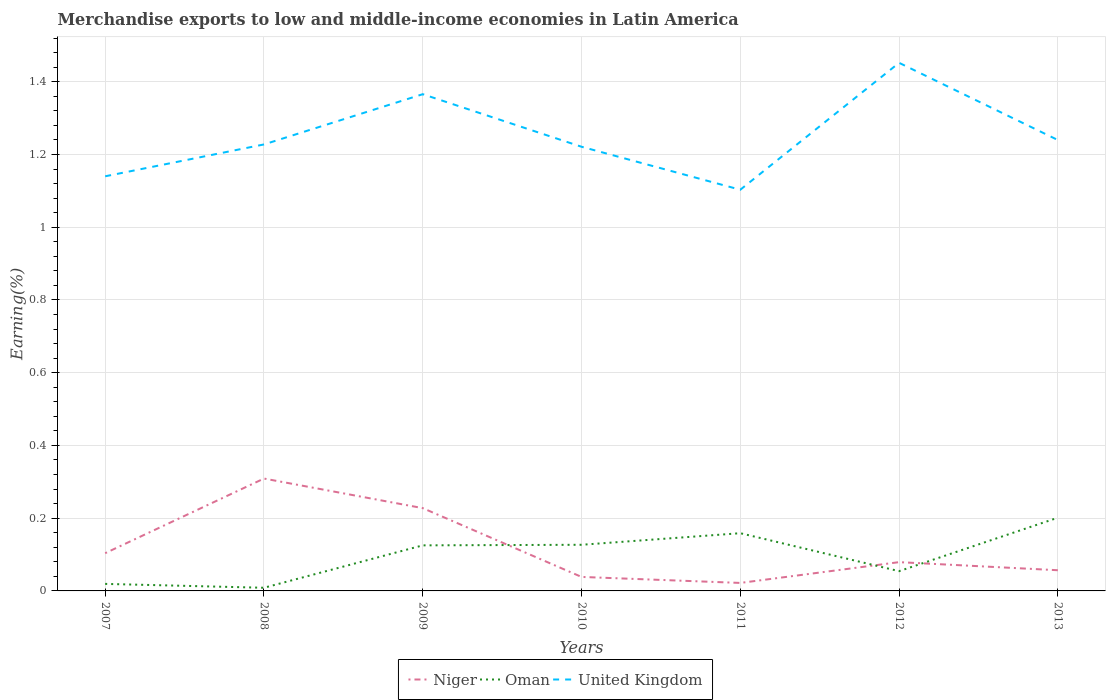How many different coloured lines are there?
Offer a very short reply. 3. Does the line corresponding to United Kingdom intersect with the line corresponding to Niger?
Ensure brevity in your answer.  No. Across all years, what is the maximum percentage of amount earned from merchandise exports in Oman?
Your answer should be compact. 0.01. In which year was the percentage of amount earned from merchandise exports in United Kingdom maximum?
Give a very brief answer. 2011. What is the total percentage of amount earned from merchandise exports in Oman in the graph?
Offer a very short reply. 0.01. What is the difference between the highest and the second highest percentage of amount earned from merchandise exports in Oman?
Give a very brief answer. 0.19. What is the difference between the highest and the lowest percentage of amount earned from merchandise exports in United Kingdom?
Give a very brief answer. 2. How many lines are there?
Give a very brief answer. 3. How many years are there in the graph?
Your response must be concise. 7. What is the difference between two consecutive major ticks on the Y-axis?
Offer a very short reply. 0.2. Are the values on the major ticks of Y-axis written in scientific E-notation?
Your answer should be compact. No. Where does the legend appear in the graph?
Offer a terse response. Bottom center. How many legend labels are there?
Offer a terse response. 3. How are the legend labels stacked?
Provide a short and direct response. Horizontal. What is the title of the graph?
Give a very brief answer. Merchandise exports to low and middle-income economies in Latin America. Does "Ghana" appear as one of the legend labels in the graph?
Your response must be concise. No. What is the label or title of the Y-axis?
Keep it short and to the point. Earning(%). What is the Earning(%) of Niger in 2007?
Your answer should be very brief. 0.1. What is the Earning(%) in Oman in 2007?
Your answer should be very brief. 0.02. What is the Earning(%) of United Kingdom in 2007?
Make the answer very short. 1.14. What is the Earning(%) of Niger in 2008?
Provide a short and direct response. 0.31. What is the Earning(%) of Oman in 2008?
Make the answer very short. 0.01. What is the Earning(%) of United Kingdom in 2008?
Your answer should be very brief. 1.23. What is the Earning(%) in Niger in 2009?
Your answer should be compact. 0.23. What is the Earning(%) in Oman in 2009?
Offer a very short reply. 0.13. What is the Earning(%) in United Kingdom in 2009?
Make the answer very short. 1.37. What is the Earning(%) in Niger in 2010?
Offer a very short reply. 0.04. What is the Earning(%) in Oman in 2010?
Your answer should be very brief. 0.13. What is the Earning(%) in United Kingdom in 2010?
Provide a succinct answer. 1.22. What is the Earning(%) of Niger in 2011?
Ensure brevity in your answer.  0.02. What is the Earning(%) of Oman in 2011?
Provide a succinct answer. 0.16. What is the Earning(%) of United Kingdom in 2011?
Your response must be concise. 1.1. What is the Earning(%) in Niger in 2012?
Your response must be concise. 0.08. What is the Earning(%) in Oman in 2012?
Offer a very short reply. 0.05. What is the Earning(%) in United Kingdom in 2012?
Provide a short and direct response. 1.45. What is the Earning(%) of Niger in 2013?
Keep it short and to the point. 0.06. What is the Earning(%) of Oman in 2013?
Offer a very short reply. 0.2. What is the Earning(%) of United Kingdom in 2013?
Provide a succinct answer. 1.24. Across all years, what is the maximum Earning(%) of Niger?
Give a very brief answer. 0.31. Across all years, what is the maximum Earning(%) of Oman?
Make the answer very short. 0.2. Across all years, what is the maximum Earning(%) of United Kingdom?
Your answer should be compact. 1.45. Across all years, what is the minimum Earning(%) in Niger?
Keep it short and to the point. 0.02. Across all years, what is the minimum Earning(%) in Oman?
Provide a short and direct response. 0.01. Across all years, what is the minimum Earning(%) in United Kingdom?
Your response must be concise. 1.1. What is the total Earning(%) of Niger in the graph?
Offer a very short reply. 0.84. What is the total Earning(%) of Oman in the graph?
Ensure brevity in your answer.  0.69. What is the total Earning(%) of United Kingdom in the graph?
Offer a very short reply. 8.75. What is the difference between the Earning(%) in Niger in 2007 and that in 2008?
Your response must be concise. -0.21. What is the difference between the Earning(%) of Oman in 2007 and that in 2008?
Give a very brief answer. 0.01. What is the difference between the Earning(%) in United Kingdom in 2007 and that in 2008?
Provide a succinct answer. -0.09. What is the difference between the Earning(%) in Niger in 2007 and that in 2009?
Offer a very short reply. -0.12. What is the difference between the Earning(%) in Oman in 2007 and that in 2009?
Ensure brevity in your answer.  -0.11. What is the difference between the Earning(%) in United Kingdom in 2007 and that in 2009?
Your response must be concise. -0.23. What is the difference between the Earning(%) of Niger in 2007 and that in 2010?
Make the answer very short. 0.07. What is the difference between the Earning(%) of Oman in 2007 and that in 2010?
Your answer should be compact. -0.11. What is the difference between the Earning(%) in United Kingdom in 2007 and that in 2010?
Provide a succinct answer. -0.08. What is the difference between the Earning(%) of Niger in 2007 and that in 2011?
Make the answer very short. 0.08. What is the difference between the Earning(%) of Oman in 2007 and that in 2011?
Keep it short and to the point. -0.14. What is the difference between the Earning(%) of United Kingdom in 2007 and that in 2011?
Your answer should be very brief. 0.04. What is the difference between the Earning(%) in Niger in 2007 and that in 2012?
Offer a very short reply. 0.02. What is the difference between the Earning(%) of Oman in 2007 and that in 2012?
Provide a succinct answer. -0.04. What is the difference between the Earning(%) of United Kingdom in 2007 and that in 2012?
Give a very brief answer. -0.31. What is the difference between the Earning(%) in Niger in 2007 and that in 2013?
Keep it short and to the point. 0.05. What is the difference between the Earning(%) of Oman in 2007 and that in 2013?
Offer a very short reply. -0.18. What is the difference between the Earning(%) in United Kingdom in 2007 and that in 2013?
Make the answer very short. -0.1. What is the difference between the Earning(%) of Niger in 2008 and that in 2009?
Keep it short and to the point. 0.08. What is the difference between the Earning(%) in Oman in 2008 and that in 2009?
Your answer should be very brief. -0.12. What is the difference between the Earning(%) in United Kingdom in 2008 and that in 2009?
Give a very brief answer. -0.14. What is the difference between the Earning(%) in Niger in 2008 and that in 2010?
Provide a short and direct response. 0.27. What is the difference between the Earning(%) of Oman in 2008 and that in 2010?
Offer a very short reply. -0.12. What is the difference between the Earning(%) in United Kingdom in 2008 and that in 2010?
Give a very brief answer. 0.01. What is the difference between the Earning(%) in Niger in 2008 and that in 2011?
Provide a succinct answer. 0.29. What is the difference between the Earning(%) of United Kingdom in 2008 and that in 2011?
Keep it short and to the point. 0.12. What is the difference between the Earning(%) in Niger in 2008 and that in 2012?
Your response must be concise. 0.23. What is the difference between the Earning(%) in Oman in 2008 and that in 2012?
Your response must be concise. -0.05. What is the difference between the Earning(%) in United Kingdom in 2008 and that in 2012?
Offer a very short reply. -0.22. What is the difference between the Earning(%) of Niger in 2008 and that in 2013?
Keep it short and to the point. 0.25. What is the difference between the Earning(%) of Oman in 2008 and that in 2013?
Make the answer very short. -0.19. What is the difference between the Earning(%) of United Kingdom in 2008 and that in 2013?
Your response must be concise. -0.01. What is the difference between the Earning(%) in Niger in 2009 and that in 2010?
Your answer should be very brief. 0.19. What is the difference between the Earning(%) of Oman in 2009 and that in 2010?
Your response must be concise. -0. What is the difference between the Earning(%) in United Kingdom in 2009 and that in 2010?
Provide a short and direct response. 0.14. What is the difference between the Earning(%) in Niger in 2009 and that in 2011?
Provide a short and direct response. 0.21. What is the difference between the Earning(%) of Oman in 2009 and that in 2011?
Your answer should be very brief. -0.03. What is the difference between the Earning(%) in United Kingdom in 2009 and that in 2011?
Your answer should be compact. 0.26. What is the difference between the Earning(%) of Niger in 2009 and that in 2012?
Your response must be concise. 0.15. What is the difference between the Earning(%) of Oman in 2009 and that in 2012?
Give a very brief answer. 0.07. What is the difference between the Earning(%) in United Kingdom in 2009 and that in 2012?
Keep it short and to the point. -0.09. What is the difference between the Earning(%) of Niger in 2009 and that in 2013?
Your answer should be very brief. 0.17. What is the difference between the Earning(%) of Oman in 2009 and that in 2013?
Your answer should be very brief. -0.08. What is the difference between the Earning(%) of United Kingdom in 2009 and that in 2013?
Offer a very short reply. 0.13. What is the difference between the Earning(%) of Niger in 2010 and that in 2011?
Make the answer very short. 0.02. What is the difference between the Earning(%) in Oman in 2010 and that in 2011?
Offer a terse response. -0.03. What is the difference between the Earning(%) in United Kingdom in 2010 and that in 2011?
Your response must be concise. 0.12. What is the difference between the Earning(%) in Niger in 2010 and that in 2012?
Provide a short and direct response. -0.04. What is the difference between the Earning(%) in Oman in 2010 and that in 2012?
Ensure brevity in your answer.  0.07. What is the difference between the Earning(%) of United Kingdom in 2010 and that in 2012?
Give a very brief answer. -0.23. What is the difference between the Earning(%) of Niger in 2010 and that in 2013?
Keep it short and to the point. -0.02. What is the difference between the Earning(%) of Oman in 2010 and that in 2013?
Keep it short and to the point. -0.07. What is the difference between the Earning(%) of United Kingdom in 2010 and that in 2013?
Your answer should be compact. -0.02. What is the difference between the Earning(%) in Niger in 2011 and that in 2012?
Ensure brevity in your answer.  -0.06. What is the difference between the Earning(%) in Oman in 2011 and that in 2012?
Make the answer very short. 0.1. What is the difference between the Earning(%) in United Kingdom in 2011 and that in 2012?
Provide a succinct answer. -0.35. What is the difference between the Earning(%) of Niger in 2011 and that in 2013?
Provide a short and direct response. -0.03. What is the difference between the Earning(%) in Oman in 2011 and that in 2013?
Provide a succinct answer. -0.04. What is the difference between the Earning(%) of United Kingdom in 2011 and that in 2013?
Give a very brief answer. -0.14. What is the difference between the Earning(%) in Niger in 2012 and that in 2013?
Make the answer very short. 0.02. What is the difference between the Earning(%) in Oman in 2012 and that in 2013?
Offer a terse response. -0.15. What is the difference between the Earning(%) in United Kingdom in 2012 and that in 2013?
Ensure brevity in your answer.  0.21. What is the difference between the Earning(%) of Niger in 2007 and the Earning(%) of Oman in 2008?
Offer a terse response. 0.1. What is the difference between the Earning(%) in Niger in 2007 and the Earning(%) in United Kingdom in 2008?
Ensure brevity in your answer.  -1.12. What is the difference between the Earning(%) of Oman in 2007 and the Earning(%) of United Kingdom in 2008?
Offer a very short reply. -1.21. What is the difference between the Earning(%) in Niger in 2007 and the Earning(%) in Oman in 2009?
Provide a succinct answer. -0.02. What is the difference between the Earning(%) in Niger in 2007 and the Earning(%) in United Kingdom in 2009?
Give a very brief answer. -1.26. What is the difference between the Earning(%) in Oman in 2007 and the Earning(%) in United Kingdom in 2009?
Offer a terse response. -1.35. What is the difference between the Earning(%) of Niger in 2007 and the Earning(%) of Oman in 2010?
Your answer should be very brief. -0.02. What is the difference between the Earning(%) in Niger in 2007 and the Earning(%) in United Kingdom in 2010?
Your answer should be compact. -1.12. What is the difference between the Earning(%) in Oman in 2007 and the Earning(%) in United Kingdom in 2010?
Offer a very short reply. -1.2. What is the difference between the Earning(%) of Niger in 2007 and the Earning(%) of Oman in 2011?
Your answer should be compact. -0.06. What is the difference between the Earning(%) of Niger in 2007 and the Earning(%) of United Kingdom in 2011?
Make the answer very short. -1. What is the difference between the Earning(%) of Oman in 2007 and the Earning(%) of United Kingdom in 2011?
Provide a succinct answer. -1.08. What is the difference between the Earning(%) of Niger in 2007 and the Earning(%) of Oman in 2012?
Keep it short and to the point. 0.05. What is the difference between the Earning(%) of Niger in 2007 and the Earning(%) of United Kingdom in 2012?
Provide a succinct answer. -1.35. What is the difference between the Earning(%) of Oman in 2007 and the Earning(%) of United Kingdom in 2012?
Provide a succinct answer. -1.43. What is the difference between the Earning(%) of Niger in 2007 and the Earning(%) of Oman in 2013?
Give a very brief answer. -0.1. What is the difference between the Earning(%) in Niger in 2007 and the Earning(%) in United Kingdom in 2013?
Make the answer very short. -1.14. What is the difference between the Earning(%) of Oman in 2007 and the Earning(%) of United Kingdom in 2013?
Provide a succinct answer. -1.22. What is the difference between the Earning(%) in Niger in 2008 and the Earning(%) in Oman in 2009?
Provide a short and direct response. 0.18. What is the difference between the Earning(%) in Niger in 2008 and the Earning(%) in United Kingdom in 2009?
Provide a succinct answer. -1.06. What is the difference between the Earning(%) of Oman in 2008 and the Earning(%) of United Kingdom in 2009?
Give a very brief answer. -1.36. What is the difference between the Earning(%) of Niger in 2008 and the Earning(%) of Oman in 2010?
Keep it short and to the point. 0.18. What is the difference between the Earning(%) in Niger in 2008 and the Earning(%) in United Kingdom in 2010?
Offer a very short reply. -0.91. What is the difference between the Earning(%) in Oman in 2008 and the Earning(%) in United Kingdom in 2010?
Keep it short and to the point. -1.21. What is the difference between the Earning(%) of Niger in 2008 and the Earning(%) of Oman in 2011?
Your response must be concise. 0.15. What is the difference between the Earning(%) of Niger in 2008 and the Earning(%) of United Kingdom in 2011?
Ensure brevity in your answer.  -0.79. What is the difference between the Earning(%) in Oman in 2008 and the Earning(%) in United Kingdom in 2011?
Your answer should be very brief. -1.09. What is the difference between the Earning(%) of Niger in 2008 and the Earning(%) of Oman in 2012?
Your answer should be compact. 0.25. What is the difference between the Earning(%) of Niger in 2008 and the Earning(%) of United Kingdom in 2012?
Offer a very short reply. -1.14. What is the difference between the Earning(%) in Oman in 2008 and the Earning(%) in United Kingdom in 2012?
Provide a succinct answer. -1.44. What is the difference between the Earning(%) in Niger in 2008 and the Earning(%) in Oman in 2013?
Your answer should be compact. 0.11. What is the difference between the Earning(%) of Niger in 2008 and the Earning(%) of United Kingdom in 2013?
Ensure brevity in your answer.  -0.93. What is the difference between the Earning(%) in Oman in 2008 and the Earning(%) in United Kingdom in 2013?
Give a very brief answer. -1.23. What is the difference between the Earning(%) of Niger in 2009 and the Earning(%) of Oman in 2010?
Offer a terse response. 0.1. What is the difference between the Earning(%) of Niger in 2009 and the Earning(%) of United Kingdom in 2010?
Provide a short and direct response. -0.99. What is the difference between the Earning(%) of Oman in 2009 and the Earning(%) of United Kingdom in 2010?
Your answer should be very brief. -1.1. What is the difference between the Earning(%) of Niger in 2009 and the Earning(%) of Oman in 2011?
Ensure brevity in your answer.  0.07. What is the difference between the Earning(%) of Niger in 2009 and the Earning(%) of United Kingdom in 2011?
Your response must be concise. -0.88. What is the difference between the Earning(%) of Oman in 2009 and the Earning(%) of United Kingdom in 2011?
Keep it short and to the point. -0.98. What is the difference between the Earning(%) in Niger in 2009 and the Earning(%) in Oman in 2012?
Your response must be concise. 0.17. What is the difference between the Earning(%) of Niger in 2009 and the Earning(%) of United Kingdom in 2012?
Offer a terse response. -1.22. What is the difference between the Earning(%) in Oman in 2009 and the Earning(%) in United Kingdom in 2012?
Give a very brief answer. -1.33. What is the difference between the Earning(%) of Niger in 2009 and the Earning(%) of Oman in 2013?
Give a very brief answer. 0.03. What is the difference between the Earning(%) of Niger in 2009 and the Earning(%) of United Kingdom in 2013?
Provide a succinct answer. -1.01. What is the difference between the Earning(%) of Oman in 2009 and the Earning(%) of United Kingdom in 2013?
Offer a terse response. -1.11. What is the difference between the Earning(%) of Niger in 2010 and the Earning(%) of Oman in 2011?
Make the answer very short. -0.12. What is the difference between the Earning(%) of Niger in 2010 and the Earning(%) of United Kingdom in 2011?
Your answer should be compact. -1.06. What is the difference between the Earning(%) in Oman in 2010 and the Earning(%) in United Kingdom in 2011?
Make the answer very short. -0.98. What is the difference between the Earning(%) of Niger in 2010 and the Earning(%) of Oman in 2012?
Keep it short and to the point. -0.02. What is the difference between the Earning(%) of Niger in 2010 and the Earning(%) of United Kingdom in 2012?
Your answer should be very brief. -1.41. What is the difference between the Earning(%) of Oman in 2010 and the Earning(%) of United Kingdom in 2012?
Give a very brief answer. -1.33. What is the difference between the Earning(%) in Niger in 2010 and the Earning(%) in Oman in 2013?
Offer a terse response. -0.16. What is the difference between the Earning(%) in Niger in 2010 and the Earning(%) in United Kingdom in 2013?
Offer a terse response. -1.2. What is the difference between the Earning(%) in Oman in 2010 and the Earning(%) in United Kingdom in 2013?
Your response must be concise. -1.11. What is the difference between the Earning(%) of Niger in 2011 and the Earning(%) of Oman in 2012?
Your answer should be very brief. -0.03. What is the difference between the Earning(%) in Niger in 2011 and the Earning(%) in United Kingdom in 2012?
Keep it short and to the point. -1.43. What is the difference between the Earning(%) of Oman in 2011 and the Earning(%) of United Kingdom in 2012?
Ensure brevity in your answer.  -1.29. What is the difference between the Earning(%) in Niger in 2011 and the Earning(%) in Oman in 2013?
Provide a short and direct response. -0.18. What is the difference between the Earning(%) in Niger in 2011 and the Earning(%) in United Kingdom in 2013?
Your response must be concise. -1.22. What is the difference between the Earning(%) in Oman in 2011 and the Earning(%) in United Kingdom in 2013?
Keep it short and to the point. -1.08. What is the difference between the Earning(%) in Niger in 2012 and the Earning(%) in Oman in 2013?
Make the answer very short. -0.12. What is the difference between the Earning(%) in Niger in 2012 and the Earning(%) in United Kingdom in 2013?
Your answer should be very brief. -1.16. What is the difference between the Earning(%) in Oman in 2012 and the Earning(%) in United Kingdom in 2013?
Provide a succinct answer. -1.19. What is the average Earning(%) of Niger per year?
Your answer should be very brief. 0.12. What is the average Earning(%) of Oman per year?
Offer a terse response. 0.1. What is the average Earning(%) of United Kingdom per year?
Offer a very short reply. 1.25. In the year 2007, what is the difference between the Earning(%) in Niger and Earning(%) in Oman?
Provide a succinct answer. 0.08. In the year 2007, what is the difference between the Earning(%) in Niger and Earning(%) in United Kingdom?
Provide a short and direct response. -1.04. In the year 2007, what is the difference between the Earning(%) of Oman and Earning(%) of United Kingdom?
Offer a very short reply. -1.12. In the year 2008, what is the difference between the Earning(%) in Niger and Earning(%) in Oman?
Provide a succinct answer. 0.3. In the year 2008, what is the difference between the Earning(%) in Niger and Earning(%) in United Kingdom?
Your answer should be very brief. -0.92. In the year 2008, what is the difference between the Earning(%) of Oman and Earning(%) of United Kingdom?
Keep it short and to the point. -1.22. In the year 2009, what is the difference between the Earning(%) in Niger and Earning(%) in Oman?
Your response must be concise. 0.1. In the year 2009, what is the difference between the Earning(%) of Niger and Earning(%) of United Kingdom?
Your response must be concise. -1.14. In the year 2009, what is the difference between the Earning(%) in Oman and Earning(%) in United Kingdom?
Provide a short and direct response. -1.24. In the year 2010, what is the difference between the Earning(%) of Niger and Earning(%) of Oman?
Give a very brief answer. -0.09. In the year 2010, what is the difference between the Earning(%) of Niger and Earning(%) of United Kingdom?
Your response must be concise. -1.18. In the year 2010, what is the difference between the Earning(%) of Oman and Earning(%) of United Kingdom?
Offer a very short reply. -1.09. In the year 2011, what is the difference between the Earning(%) of Niger and Earning(%) of Oman?
Offer a very short reply. -0.14. In the year 2011, what is the difference between the Earning(%) in Niger and Earning(%) in United Kingdom?
Make the answer very short. -1.08. In the year 2011, what is the difference between the Earning(%) in Oman and Earning(%) in United Kingdom?
Give a very brief answer. -0.94. In the year 2012, what is the difference between the Earning(%) of Niger and Earning(%) of Oman?
Give a very brief answer. 0.02. In the year 2012, what is the difference between the Earning(%) of Niger and Earning(%) of United Kingdom?
Make the answer very short. -1.37. In the year 2012, what is the difference between the Earning(%) of Oman and Earning(%) of United Kingdom?
Give a very brief answer. -1.4. In the year 2013, what is the difference between the Earning(%) in Niger and Earning(%) in Oman?
Provide a short and direct response. -0.14. In the year 2013, what is the difference between the Earning(%) in Niger and Earning(%) in United Kingdom?
Your answer should be very brief. -1.18. In the year 2013, what is the difference between the Earning(%) in Oman and Earning(%) in United Kingdom?
Your answer should be very brief. -1.04. What is the ratio of the Earning(%) of Niger in 2007 to that in 2008?
Offer a terse response. 0.34. What is the ratio of the Earning(%) in Oman in 2007 to that in 2008?
Keep it short and to the point. 2.23. What is the ratio of the Earning(%) of United Kingdom in 2007 to that in 2008?
Your answer should be very brief. 0.93. What is the ratio of the Earning(%) of Niger in 2007 to that in 2009?
Keep it short and to the point. 0.46. What is the ratio of the Earning(%) in Oman in 2007 to that in 2009?
Your answer should be very brief. 0.15. What is the ratio of the Earning(%) in United Kingdom in 2007 to that in 2009?
Your answer should be compact. 0.83. What is the ratio of the Earning(%) in Niger in 2007 to that in 2010?
Give a very brief answer. 2.7. What is the ratio of the Earning(%) in Oman in 2007 to that in 2010?
Make the answer very short. 0.15. What is the ratio of the Earning(%) in United Kingdom in 2007 to that in 2010?
Give a very brief answer. 0.93. What is the ratio of the Earning(%) of Niger in 2007 to that in 2011?
Give a very brief answer. 4.72. What is the ratio of the Earning(%) in Oman in 2007 to that in 2011?
Ensure brevity in your answer.  0.12. What is the ratio of the Earning(%) in United Kingdom in 2007 to that in 2011?
Provide a short and direct response. 1.03. What is the ratio of the Earning(%) in Niger in 2007 to that in 2012?
Your answer should be compact. 1.31. What is the ratio of the Earning(%) in Oman in 2007 to that in 2012?
Ensure brevity in your answer.  0.36. What is the ratio of the Earning(%) of United Kingdom in 2007 to that in 2012?
Keep it short and to the point. 0.79. What is the ratio of the Earning(%) in Niger in 2007 to that in 2013?
Offer a very short reply. 1.82. What is the ratio of the Earning(%) of Oman in 2007 to that in 2013?
Your response must be concise. 0.1. What is the ratio of the Earning(%) of United Kingdom in 2007 to that in 2013?
Provide a succinct answer. 0.92. What is the ratio of the Earning(%) of Niger in 2008 to that in 2009?
Your answer should be compact. 1.36. What is the ratio of the Earning(%) of Oman in 2008 to that in 2009?
Your answer should be very brief. 0.07. What is the ratio of the Earning(%) in United Kingdom in 2008 to that in 2009?
Provide a succinct answer. 0.9. What is the ratio of the Earning(%) in Niger in 2008 to that in 2010?
Your answer should be compact. 8.03. What is the ratio of the Earning(%) of Oman in 2008 to that in 2010?
Provide a succinct answer. 0.07. What is the ratio of the Earning(%) in United Kingdom in 2008 to that in 2010?
Make the answer very short. 1.01. What is the ratio of the Earning(%) of Niger in 2008 to that in 2011?
Your answer should be very brief. 14.06. What is the ratio of the Earning(%) of Oman in 2008 to that in 2011?
Provide a succinct answer. 0.05. What is the ratio of the Earning(%) in United Kingdom in 2008 to that in 2011?
Your response must be concise. 1.11. What is the ratio of the Earning(%) of Niger in 2008 to that in 2012?
Ensure brevity in your answer.  3.9. What is the ratio of the Earning(%) in Oman in 2008 to that in 2012?
Make the answer very short. 0.16. What is the ratio of the Earning(%) of United Kingdom in 2008 to that in 2012?
Your response must be concise. 0.85. What is the ratio of the Earning(%) of Niger in 2008 to that in 2013?
Provide a succinct answer. 5.43. What is the ratio of the Earning(%) in Oman in 2008 to that in 2013?
Your response must be concise. 0.04. What is the ratio of the Earning(%) of United Kingdom in 2008 to that in 2013?
Offer a very short reply. 0.99. What is the ratio of the Earning(%) in Niger in 2009 to that in 2010?
Provide a succinct answer. 5.91. What is the ratio of the Earning(%) in Oman in 2009 to that in 2010?
Keep it short and to the point. 0.99. What is the ratio of the Earning(%) of United Kingdom in 2009 to that in 2010?
Provide a succinct answer. 1.12. What is the ratio of the Earning(%) of Niger in 2009 to that in 2011?
Provide a succinct answer. 10.36. What is the ratio of the Earning(%) of Oman in 2009 to that in 2011?
Your response must be concise. 0.79. What is the ratio of the Earning(%) in United Kingdom in 2009 to that in 2011?
Offer a very short reply. 1.24. What is the ratio of the Earning(%) of Niger in 2009 to that in 2012?
Offer a terse response. 2.88. What is the ratio of the Earning(%) in Oman in 2009 to that in 2012?
Offer a very short reply. 2.31. What is the ratio of the Earning(%) of United Kingdom in 2009 to that in 2012?
Make the answer very short. 0.94. What is the ratio of the Earning(%) of Niger in 2009 to that in 2013?
Provide a short and direct response. 4. What is the ratio of the Earning(%) in Oman in 2009 to that in 2013?
Ensure brevity in your answer.  0.62. What is the ratio of the Earning(%) in United Kingdom in 2009 to that in 2013?
Your response must be concise. 1.1. What is the ratio of the Earning(%) of Niger in 2010 to that in 2011?
Offer a terse response. 1.75. What is the ratio of the Earning(%) of Oman in 2010 to that in 2011?
Provide a short and direct response. 0.8. What is the ratio of the Earning(%) in United Kingdom in 2010 to that in 2011?
Ensure brevity in your answer.  1.11. What is the ratio of the Earning(%) in Niger in 2010 to that in 2012?
Ensure brevity in your answer.  0.49. What is the ratio of the Earning(%) in Oman in 2010 to that in 2012?
Offer a very short reply. 2.33. What is the ratio of the Earning(%) in United Kingdom in 2010 to that in 2012?
Offer a terse response. 0.84. What is the ratio of the Earning(%) in Niger in 2010 to that in 2013?
Provide a succinct answer. 0.68. What is the ratio of the Earning(%) in Oman in 2010 to that in 2013?
Your answer should be very brief. 0.63. What is the ratio of the Earning(%) in United Kingdom in 2010 to that in 2013?
Provide a succinct answer. 0.99. What is the ratio of the Earning(%) in Niger in 2011 to that in 2012?
Your answer should be very brief. 0.28. What is the ratio of the Earning(%) of Oman in 2011 to that in 2012?
Keep it short and to the point. 2.92. What is the ratio of the Earning(%) in United Kingdom in 2011 to that in 2012?
Give a very brief answer. 0.76. What is the ratio of the Earning(%) in Niger in 2011 to that in 2013?
Keep it short and to the point. 0.39. What is the ratio of the Earning(%) of Oman in 2011 to that in 2013?
Your response must be concise. 0.79. What is the ratio of the Earning(%) in United Kingdom in 2011 to that in 2013?
Give a very brief answer. 0.89. What is the ratio of the Earning(%) of Niger in 2012 to that in 2013?
Your answer should be very brief. 1.39. What is the ratio of the Earning(%) in Oman in 2012 to that in 2013?
Your response must be concise. 0.27. What is the ratio of the Earning(%) of United Kingdom in 2012 to that in 2013?
Give a very brief answer. 1.17. What is the difference between the highest and the second highest Earning(%) in Niger?
Ensure brevity in your answer.  0.08. What is the difference between the highest and the second highest Earning(%) of Oman?
Your answer should be compact. 0.04. What is the difference between the highest and the second highest Earning(%) of United Kingdom?
Provide a succinct answer. 0.09. What is the difference between the highest and the lowest Earning(%) of Niger?
Make the answer very short. 0.29. What is the difference between the highest and the lowest Earning(%) in Oman?
Your response must be concise. 0.19. What is the difference between the highest and the lowest Earning(%) in United Kingdom?
Offer a very short reply. 0.35. 